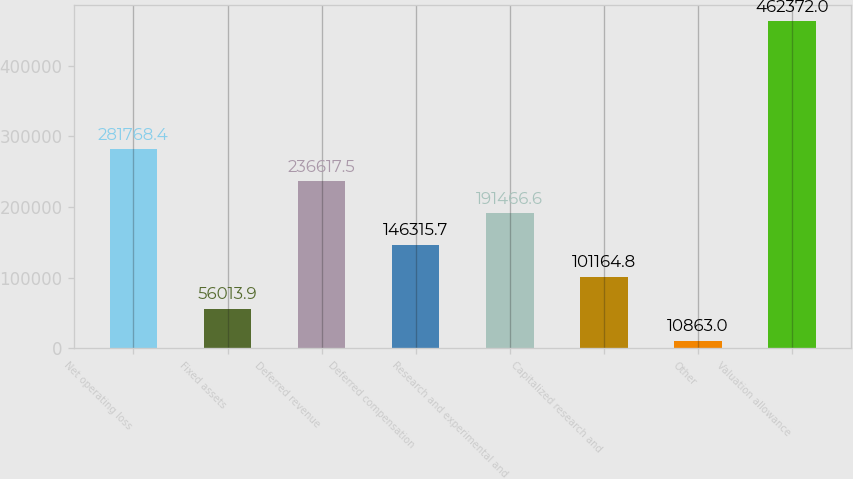<chart> <loc_0><loc_0><loc_500><loc_500><bar_chart><fcel>Net operating loss<fcel>Fixed assets<fcel>Deferred revenue<fcel>Deferred compensation<fcel>Research and experimental and<fcel>Capitalized research and<fcel>Other<fcel>Valuation allowance<nl><fcel>281768<fcel>56013.9<fcel>236618<fcel>146316<fcel>191467<fcel>101165<fcel>10863<fcel>462372<nl></chart> 